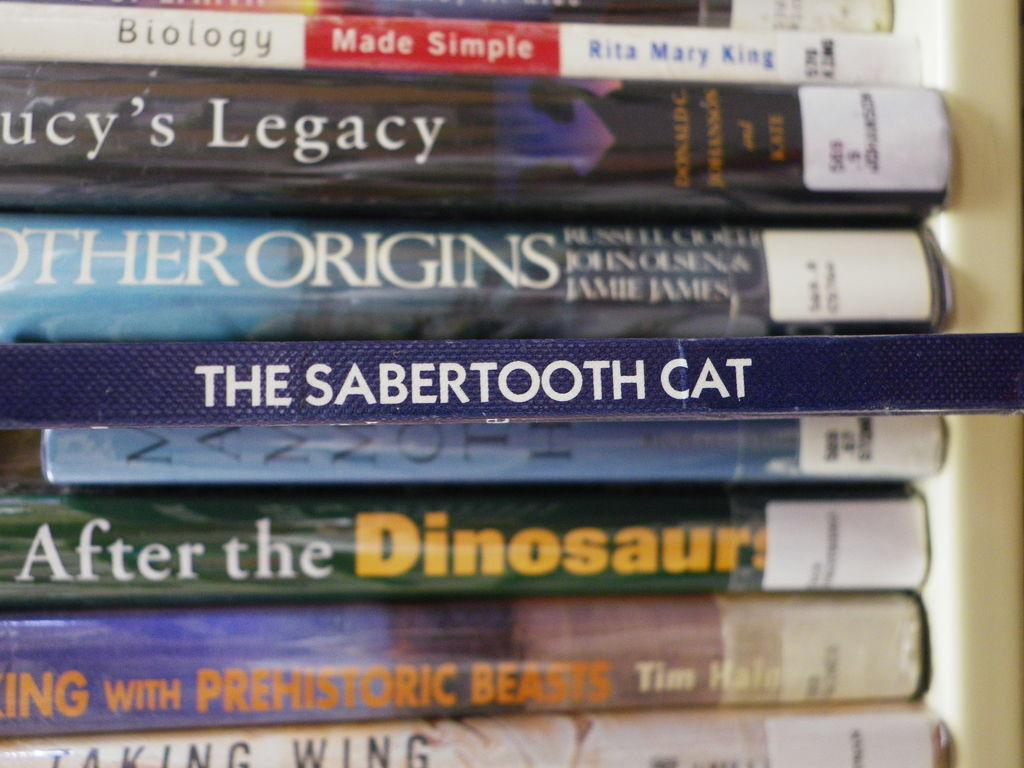<image>
Give a short and clear explanation of the subsequent image. The Sabertooth Cat sits in the middle of a stack of library books. 